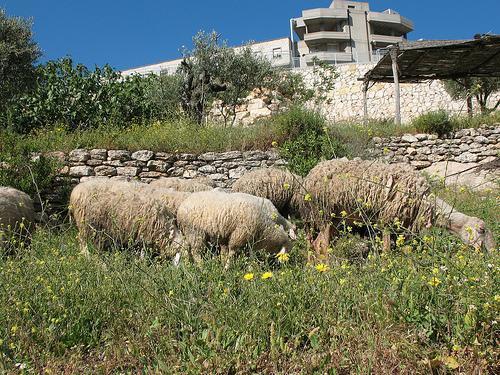How many sheep are there?
Give a very brief answer. 6. How many buildings are there?
Give a very brief answer. 1. 